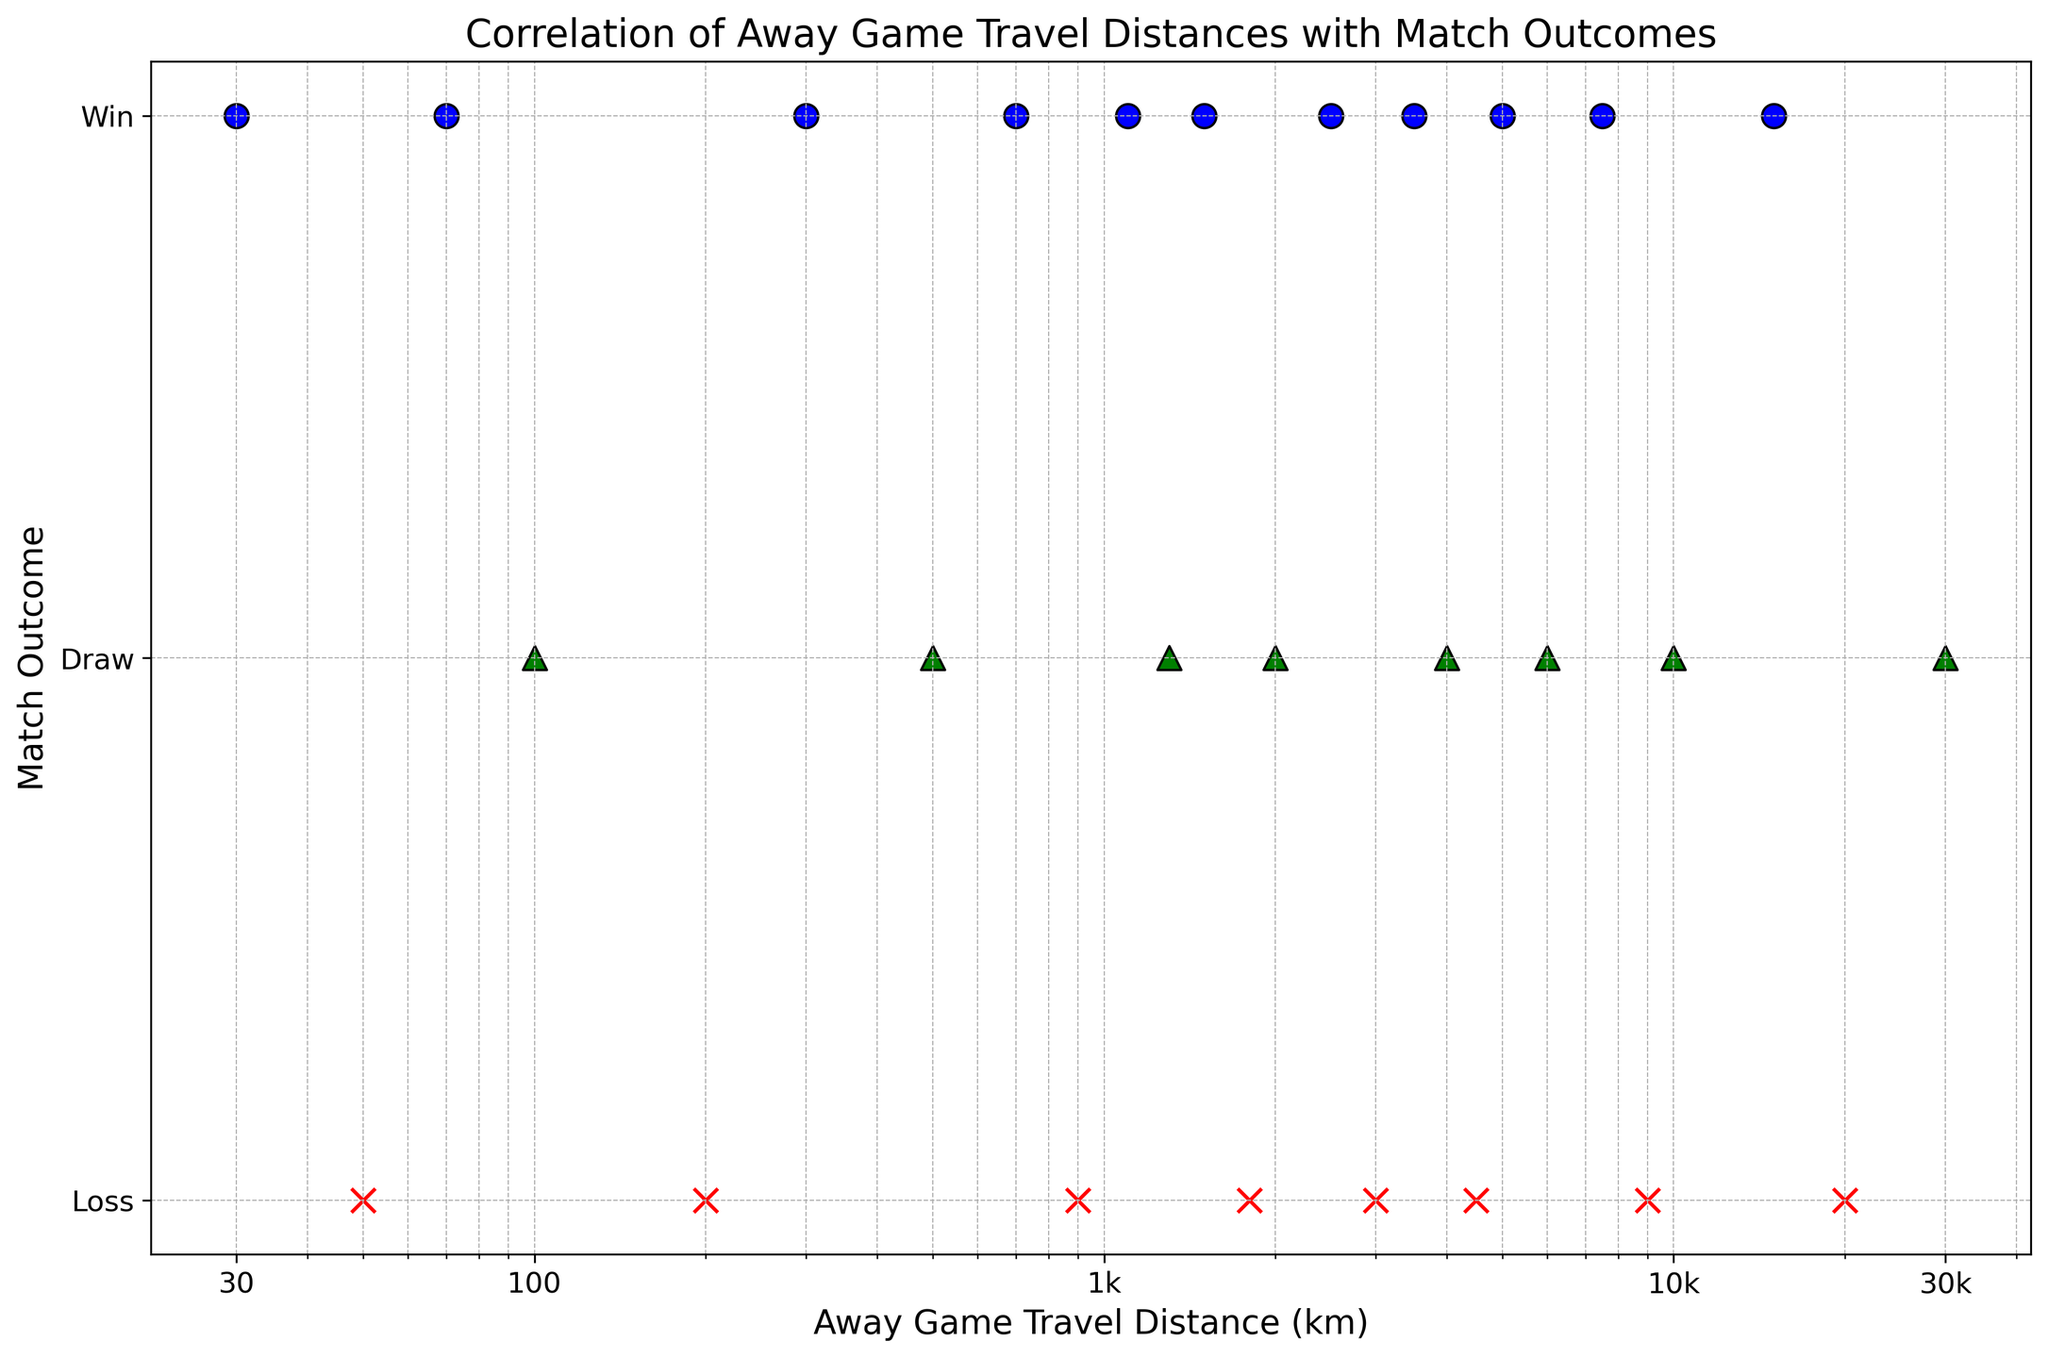How does the match outcome change as the away game travel distance increases? By observing the scatter plot, which uses a logarithmic scale on the x-axis, we notice that both wins and losses are somewhat scattered across varying distances without a clear trend. Although wins, losses, and draws are distributed across the range, no definitive pattern indicates that increased travel distance clearly affects match outcomes. We need statistical analysis for a conclusive answer.
Answer: Mixed Compare the number of losses when the away game travel distance is less than and greater than 1000 km. On the logscale x-axis, examining the red 'x' markers (which represent losses), we see there are 2 losses at distances less than 1000 km (50 km, 200 km) and 5 losses at distances greater than 1000 km (900 km, 2000 km, 3000 km, 4500 km, 7500 km, and 20000 km).
Answer: Less: 2, Greater: 5 Which range of distances (less than 1000 km or greater than 1000 km) shows more wins? Looking at the blue 'o' markers, for distances less than 1000 km, there are 3 wins (30 km, 70 km, 300 km). For distances greater than 1000 km, there are 6 wins (1100 km, 1500 km, 2500 km, 3500 km, 5000 km, and 15000 km).
Answer: Greater than 1000 km What is the most common match outcome within the distance range of 100 km to 1000 km? Within the specified distance range, there are outcomes: 100 km (draw), 200 km (loss), 300 km (win), 500 km (draw), 700 km (win), and 900 km (loss). Wins occur 2 times, draws 2 times, and losses 2 times. Therefore, all outcomes are equally common in this distance range.
Answer: Equally common How does the number of draws compare to wins and losses for away game distances above 5000 km? For distances above 5000 km, there are draws at 6000 km, 10000 km, and 30000 km (3 draws), wins are found at 15000 km (1 win), and losses at 7500 km, and 20000 km (2 losses). Therefore, the number of draws is higher compared to wins and losses.
Answer: More draws What is the farthest distance traveled for a match resulting in a win? The scatter plot shows the blue 'o' marker representing the farthest win at 15000 km.
Answer: 15000 km How does the frequency of wins compare between distances of 100 km to 1000 km and distances greater than 1000 km? In the range of 100 km to 1000 km, wins occur at 300 km and 700 km (2 wins). For distances greater than 1000 km, wins occur at 1100 km, 1500 km, 2500 km, 3500 km, 5000 km, and 15000 km (6 wins). Thus, there are more wins for distances greater than 1000 km.
Answer: More wins greater than 1000 km 